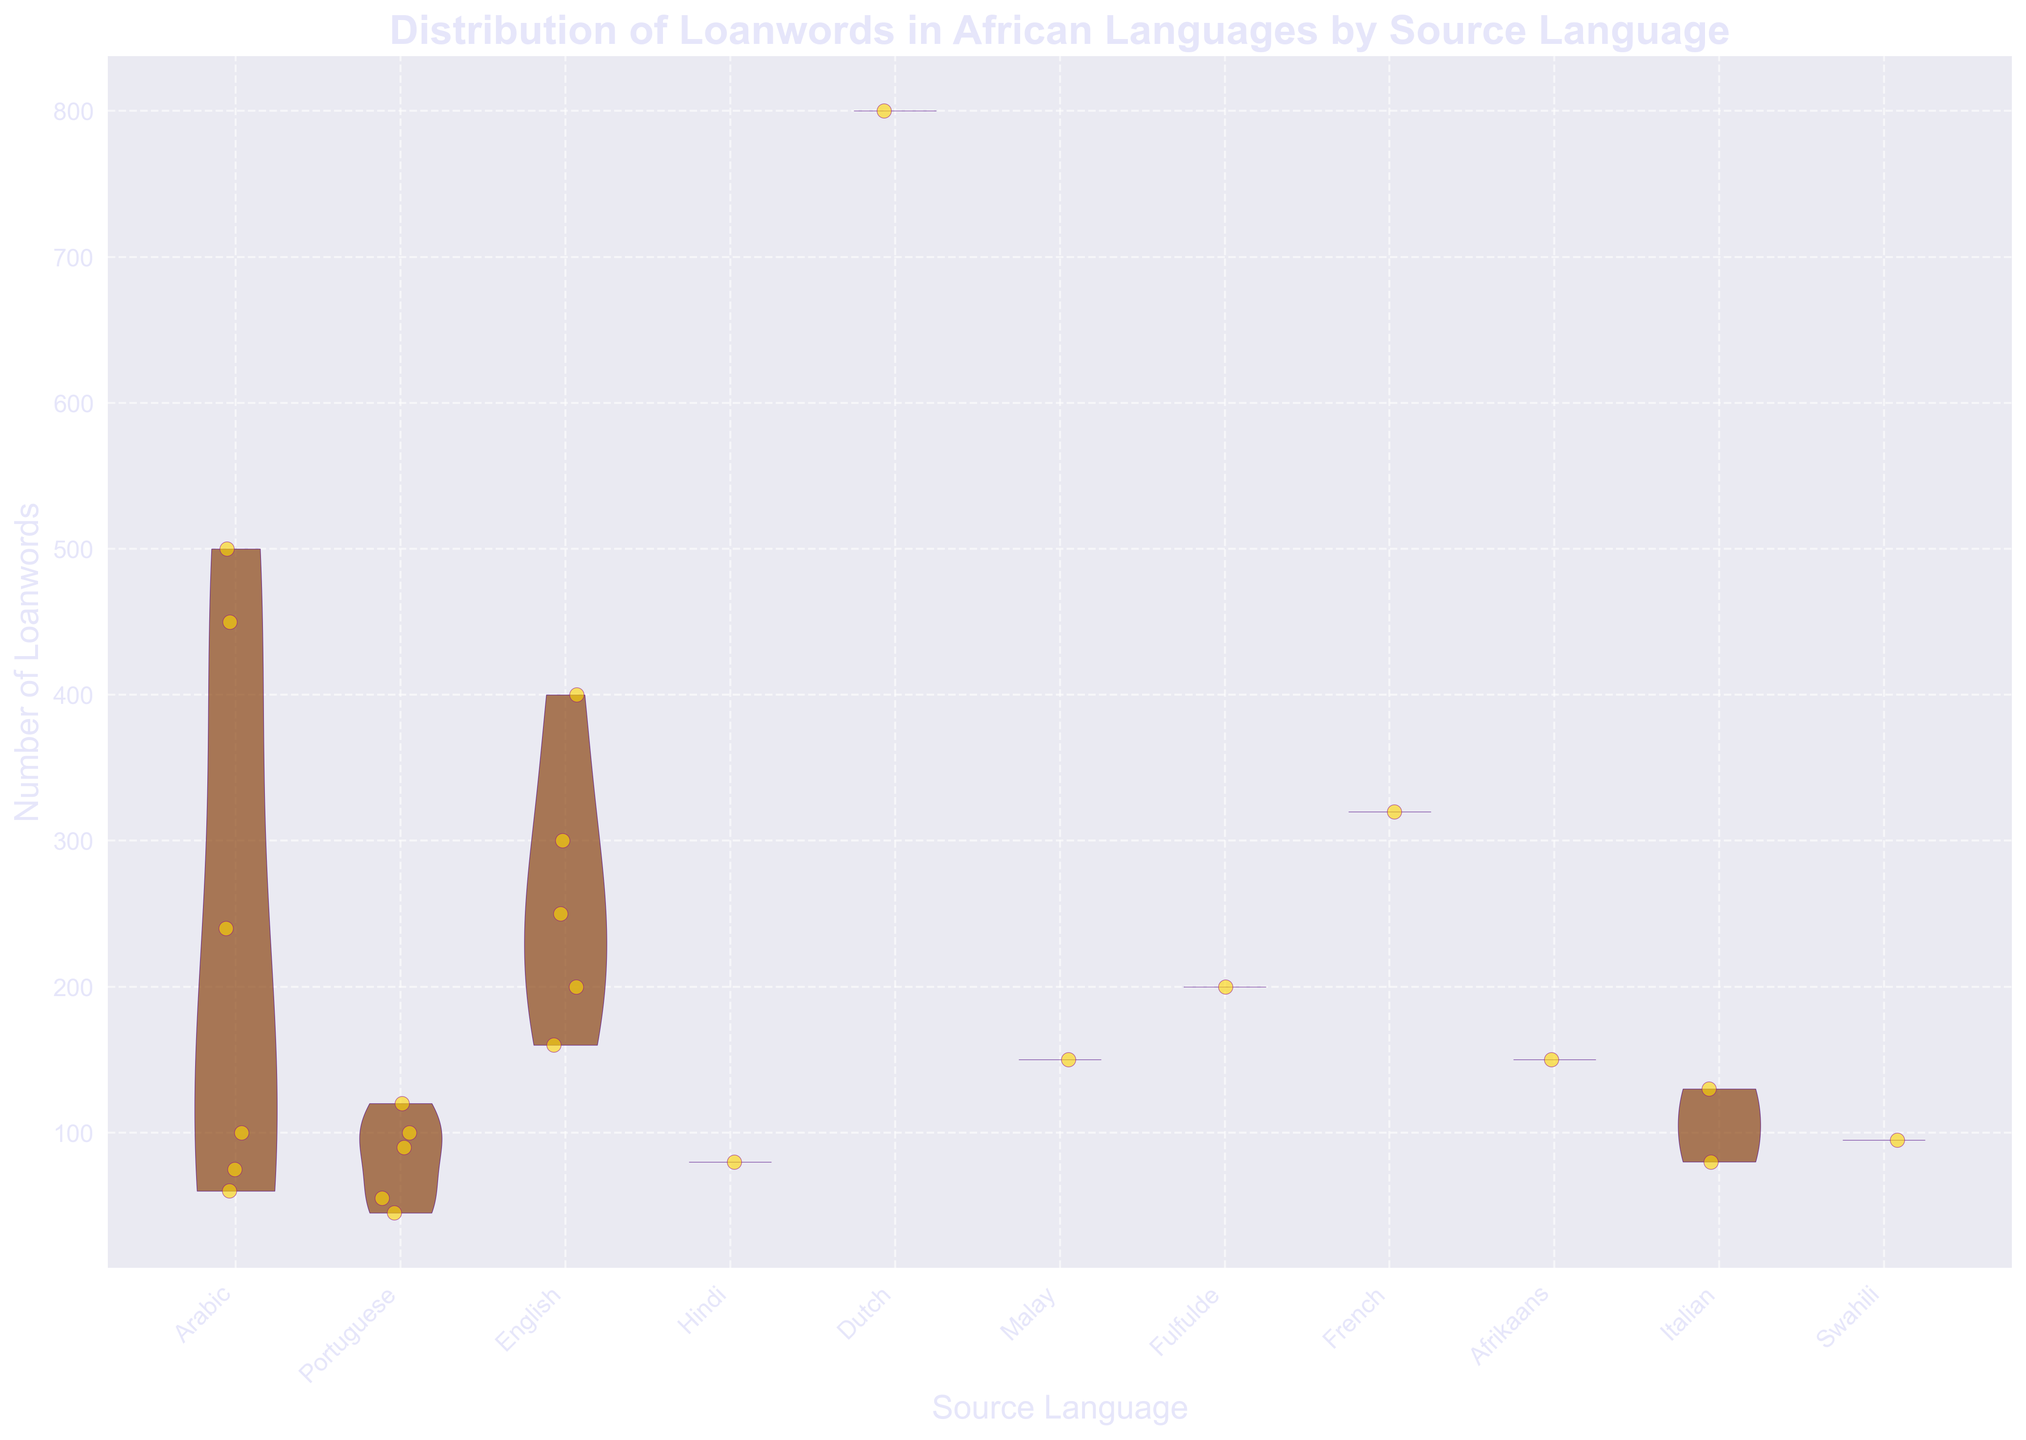What is the title of the chart? The title of the chart is prominently displayed at the top and reads "Distribution of Loanwords in African Languages by Source Language." This provides an overall understanding of what the chart represents.
Answer: Distribution of Loanwords in African Languages by Source Language Which source language has the highest number of loanwords in an African language? By observing the positions and heights of the violins and jittered points, it is clear that Dutch has the highest number of loanwords, especially evident in the Afrikaans language data.
Answer: Dutch How many source languages are displayed in the chart? The x-axis lists all unique source languages. By counting these, you can determine there are ten different source languages.
Answer: Ten Which African language has the most diverse set of source languages? Reviewing the jittered points and violins, Swahili appears to have the most diverse set of source languages, as it has loanwords from Arabic, Portuguese, English, and Hindi.
Answer: Swahili What is the range of loanwords for Arabic as a source language? To find the range, look at the spread of the jittered points for Arabic. These points span from approximately 60 to 500.
Answer: 60 to 500 Which African language has the smallest number of loanwords from a source language, and what is that source language? By examining the distribution of points, Yoruba with Portuguese as the source language has the smallest value, with about 45 loanwords.
Answer: Yoruba, Portuguese Compare the median number of loanwords in Swahili from Arabic and English. The median is visually approximated by looking for the center of the distribution of the jittered points within the violins for Swahili with Arabic and English. The median for Arabic loanwords in Swahili is higher than that for English.
Answer: Arabic What is the difference between the number of loanwords from Arabic in Hausa and Yoruba? Review the height and distribution of the jittered points for Arabic as the source language in Hausa and Yoruba. Hausa has around 500 loanwords, while Yoruba has about 60. The difference is 500 - 60.
Answer: 440 Which source language has the narrowest distribution of loanwords in African languages? The narrowness of a distribution can be seen by comparing the width of the violins. Hindi in Swahili shows a particularly narrow distribution.
Answer: Hindi Is there any African language that does not have loanwords from Arabic? To determine this, look across the chart for any African languages that do not have jittered points or violins associated with Arabic. Zulu and Wolof do not appear to have loanwords from Arabic.
Answer: Zulu and Wolof 